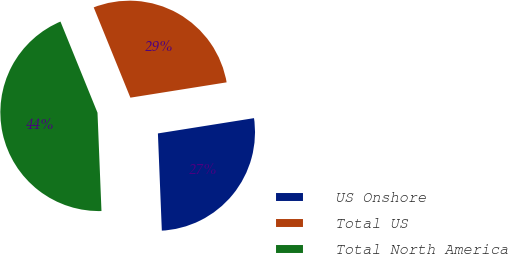Convert chart to OTSL. <chart><loc_0><loc_0><loc_500><loc_500><pie_chart><fcel>US Onshore<fcel>Total US<fcel>Total North America<nl><fcel>26.87%<fcel>28.63%<fcel>44.5%<nl></chart> 